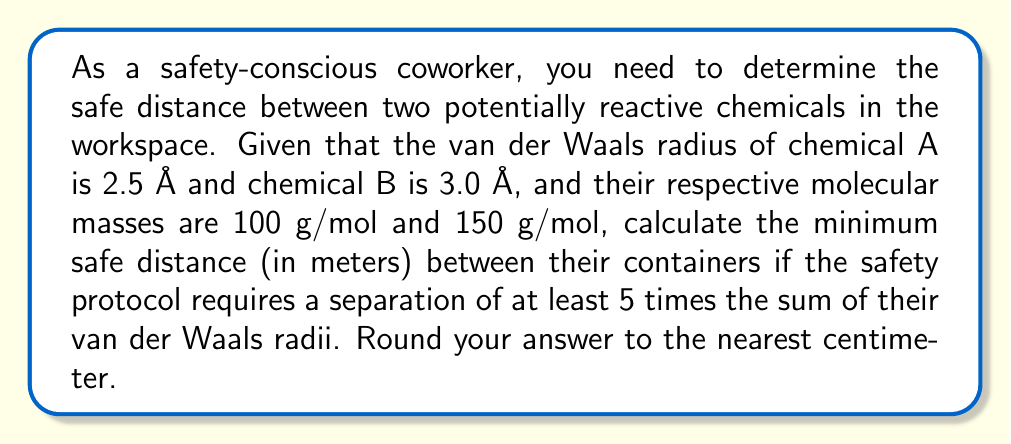Teach me how to tackle this problem. To solve this problem, we'll follow these steps:

1) First, let's calculate the sum of the van der Waals radii:
   $$ r_{total} = r_A + r_B = 2.5 \text{ Å} + 3.0 \text{ Å} = 5.5 \text{ Å} $$

2) The safety protocol requires a separation of at least 5 times this sum:
   $$ d_{safe} = 5 \times r_{total} = 5 \times 5.5 \text{ Å} = 27.5 \text{ Å} $$

3) Now, we need to convert this distance from angstroms to meters:
   $$ d_{safe} = 27.5 \text{ Å} \times \frac{1 \text{ m}}{10^{10} \text{ Å}} = 2.75 \times 10^{-9} \text{ m} $$

4) Rounding to the nearest centimeter:
   $$ d_{safe} \approx 0.01 \text{ m} = 1 \text{ cm} $$

Note: The molecular masses given in the problem are not needed for this calculation, but they could be relevant for other safety considerations.
Answer: 1 cm 